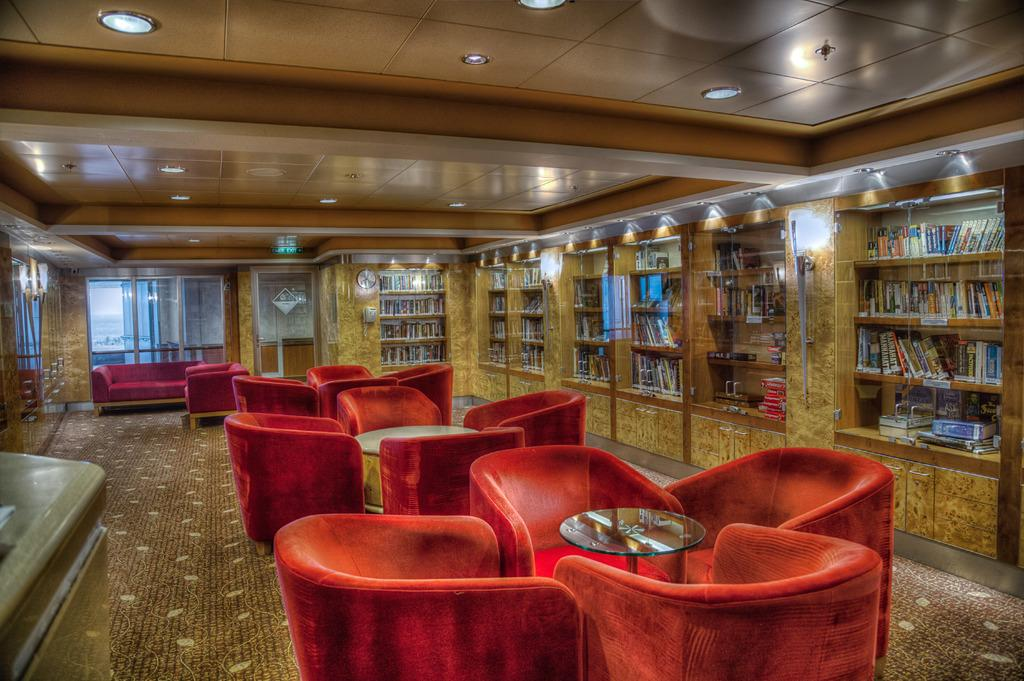What type of space is shown in the image? The image depicts a room. What furniture is present in the room? There are chairs, tables, a sofa, and cupboards in the room. What can be found inside the cupboards? Books are inside the cupboards. What architectural features are present in the room? There are windows and doors in the room. What is covering the floor in the room? Carpets are on the floor. What pen is the actor using to copy the book in the image? There is no pen, actor, or copying activity depicted in the image. 